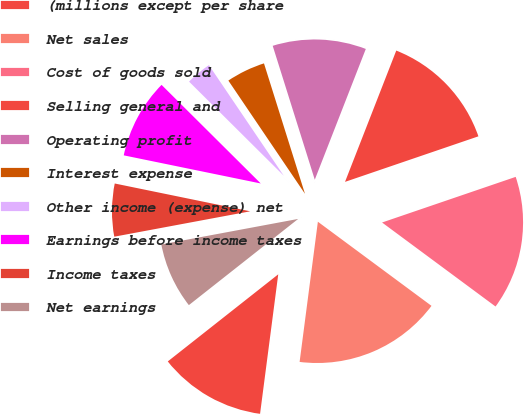Convert chart. <chart><loc_0><loc_0><loc_500><loc_500><pie_chart><fcel>(millions except per share<fcel>Net sales<fcel>Cost of goods sold<fcel>Selling general and<fcel>Operating profit<fcel>Interest expense<fcel>Other income (expense) net<fcel>Earnings before income taxes<fcel>Income taxes<fcel>Net earnings<nl><fcel>12.31%<fcel>16.92%<fcel>15.38%<fcel>13.84%<fcel>10.77%<fcel>4.62%<fcel>3.08%<fcel>9.23%<fcel>6.16%<fcel>7.69%<nl></chart> 